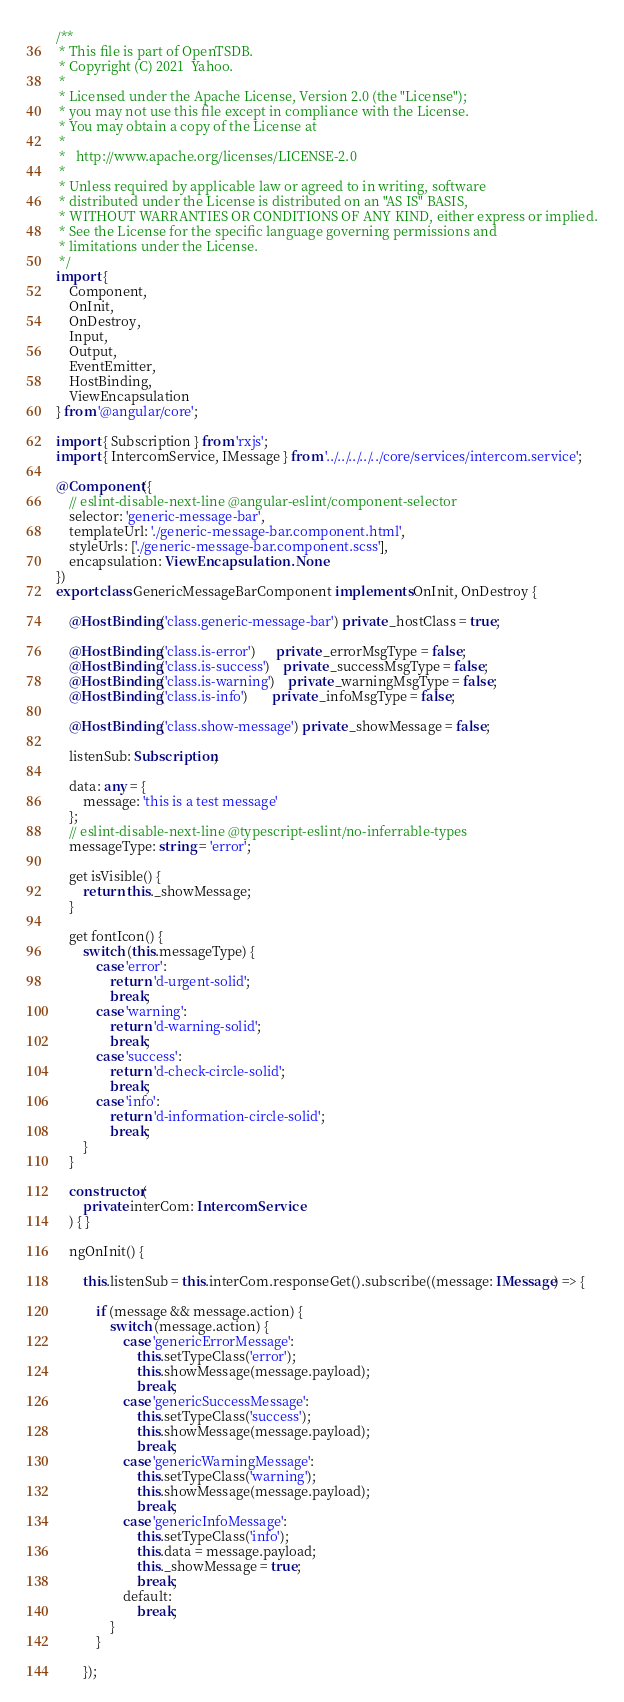Convert code to text. <code><loc_0><loc_0><loc_500><loc_500><_TypeScript_>/**
 * This file is part of OpenTSDB.
 * Copyright (C) 2021  Yahoo.
 *
 * Licensed under the Apache License, Version 2.0 (the "License");
 * you may not use this file except in compliance with the License.
 * You may obtain a copy of the License at
 *
 *   http://www.apache.org/licenses/LICENSE-2.0
 *
 * Unless required by applicable law or agreed to in writing, software
 * distributed under the License is distributed on an "AS IS" BASIS,
 * WITHOUT WARRANTIES OR CONDITIONS OF ANY KIND, either express or implied.
 * See the License for the specific language governing permissions and
 * limitations under the License.
 */
import {
    Component,
    OnInit,
    OnDestroy,
    Input,
    Output,
    EventEmitter,
    HostBinding,
    ViewEncapsulation
} from '@angular/core';

import { Subscription } from 'rxjs';
import { IntercomService, IMessage } from '../../../../../core/services/intercom.service';

@Component({
    // eslint-disable-next-line @angular-eslint/component-selector
    selector: 'generic-message-bar',
    templateUrl: './generic-message-bar.component.html',
    styleUrls: ['./generic-message-bar.component.scss'],
    encapsulation: ViewEncapsulation.None
})
export class GenericMessageBarComponent implements OnInit, OnDestroy {

    @HostBinding('class.generic-message-bar') private _hostClass = true;

    @HostBinding('class.is-error')      private _errorMsgType = false;
    @HostBinding('class.is-success')    private _successMsgType = false;
    @HostBinding('class.is-warning')    private _warningMsgType = false;
    @HostBinding('class.is-info')       private _infoMsgType = false;

    @HostBinding('class.show-message') private _showMessage = false;

    listenSub: Subscription;

    data: any = {
        message: 'this is a test message'
    };
    // eslint-disable-next-line @typescript-eslint/no-inferrable-types
    messageType: string = 'error';

    get isVisible() {
        return this._showMessage;
    }

    get fontIcon() {
        switch (this.messageType) {
            case 'error':
                return 'd-urgent-solid';
                break;
            case 'warning':
                return 'd-warning-solid';
                break;
            case 'success':
                return 'd-check-circle-solid';
                break;
            case 'info':
                return 'd-information-circle-solid';
                break;
        }
    }

    constructor(
        private interCom: IntercomService
    ) { }

    ngOnInit() {

        this.listenSub = this.interCom.responseGet().subscribe((message: IMessage) => {

            if (message && message.action) {
                switch (message.action) {
                    case 'genericErrorMessage':
                        this.setTypeClass('error');
                        this.showMessage(message.payload);
                        break;
                    case 'genericSuccessMessage':
                        this.setTypeClass('success');
                        this.showMessage(message.payload);
                        break;
                    case 'genericWarningMessage':
                        this.setTypeClass('warning');
                        this.showMessage(message.payload);
                        break;
                    case 'genericInfoMessage':
                        this.setTypeClass('info');
                        this.data = message.payload;
                        this._showMessage = true;
                        break;
                    default:
                        break;
                }
            }

        });</code> 